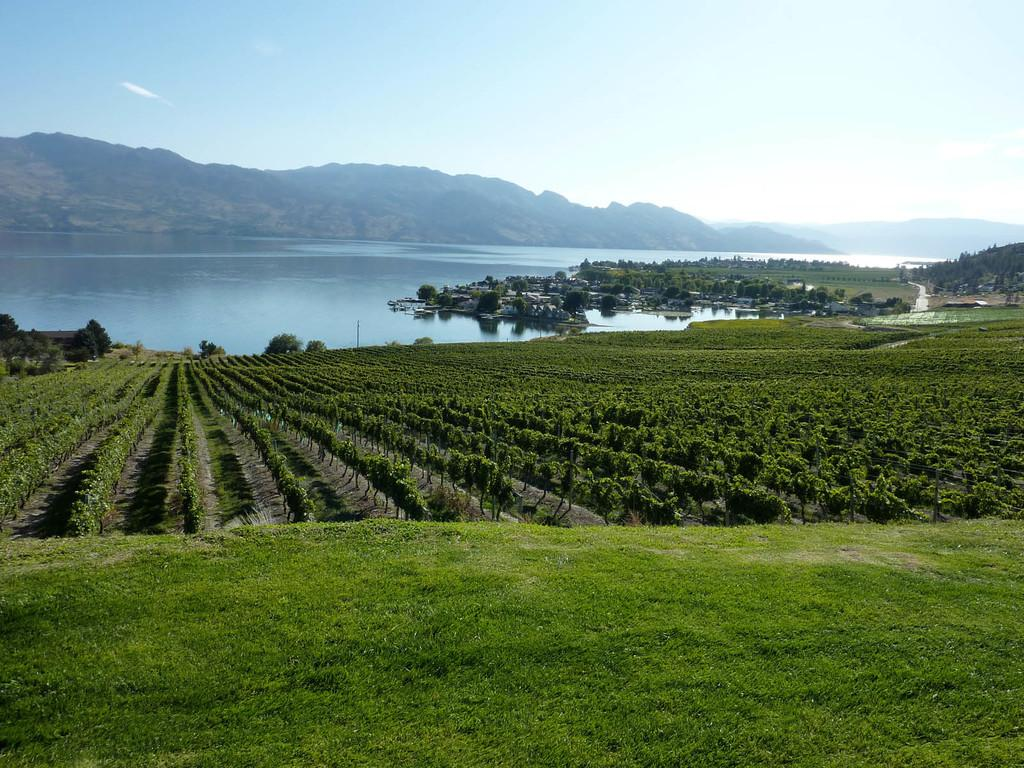What type of vegetation can be seen in the image? There is a group of trees, plants, and grass in the image. What natural feature is present in the image? There is a large water body in the image. What type of man-made structures can be seen in the image? There are buildings in the image. What geographical feature is visible in the image? There are mountains in the image. What part of the natural environment is visible in the image? The sky is visible in the image. Can you see any cream being served at the fairies' gathering in the image? There is no gathering of fairies or cream present in the image. What type of town can be seen in the image? There is no town visible in the image; it features a group of trees, plants, grass, a large water body, buildings, mountains, and the sky. 